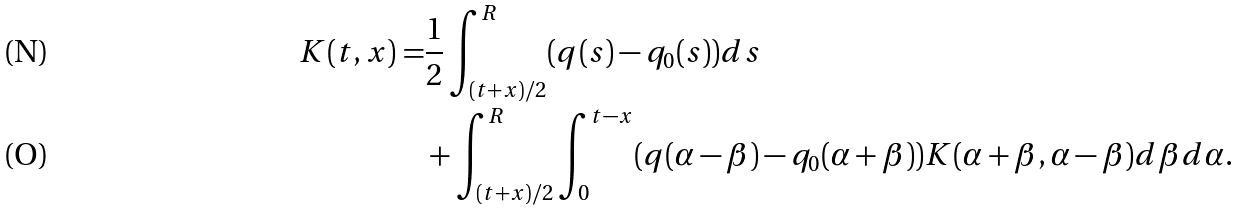<formula> <loc_0><loc_0><loc_500><loc_500>K ( t , x ) = & \frac { 1 } { 2 } \int _ { ( t + x ) / 2 } ^ { R } ( q ( s ) - q _ { 0 } ( s ) ) d s \\ & + \int _ { ( t + x ) / 2 } ^ { R } \int _ { 0 } ^ { t - x } ( q ( \alpha - \beta ) - q _ { 0 } ( \alpha + \beta ) ) K ( \alpha + \beta , \alpha - \beta ) d \beta d \alpha .</formula> 